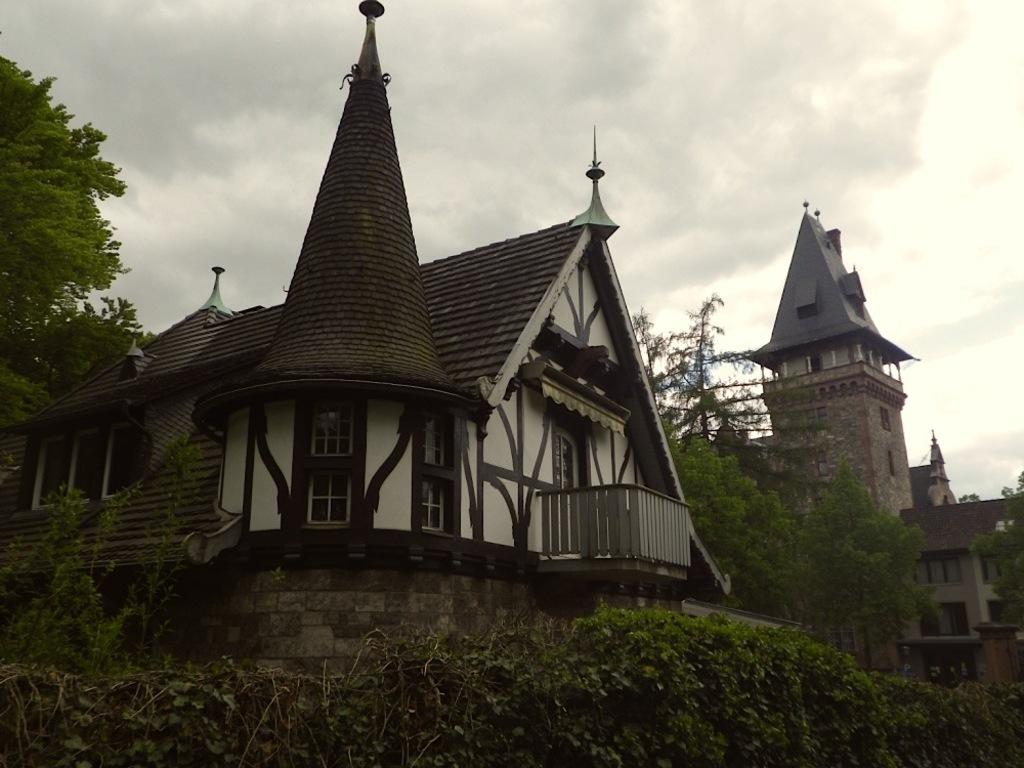What is located at the bottom of the image? There are plants at the bottom of the image. What can be seen behind the plants? There are buildings and trees behind the plants. What is visible at the top of the image? Clouds and the sky are visible at the top of the image. What idea is being expressed by the bushes in the image? There are no bushes present in the image, and therefore no ideas can be expressed by them. 